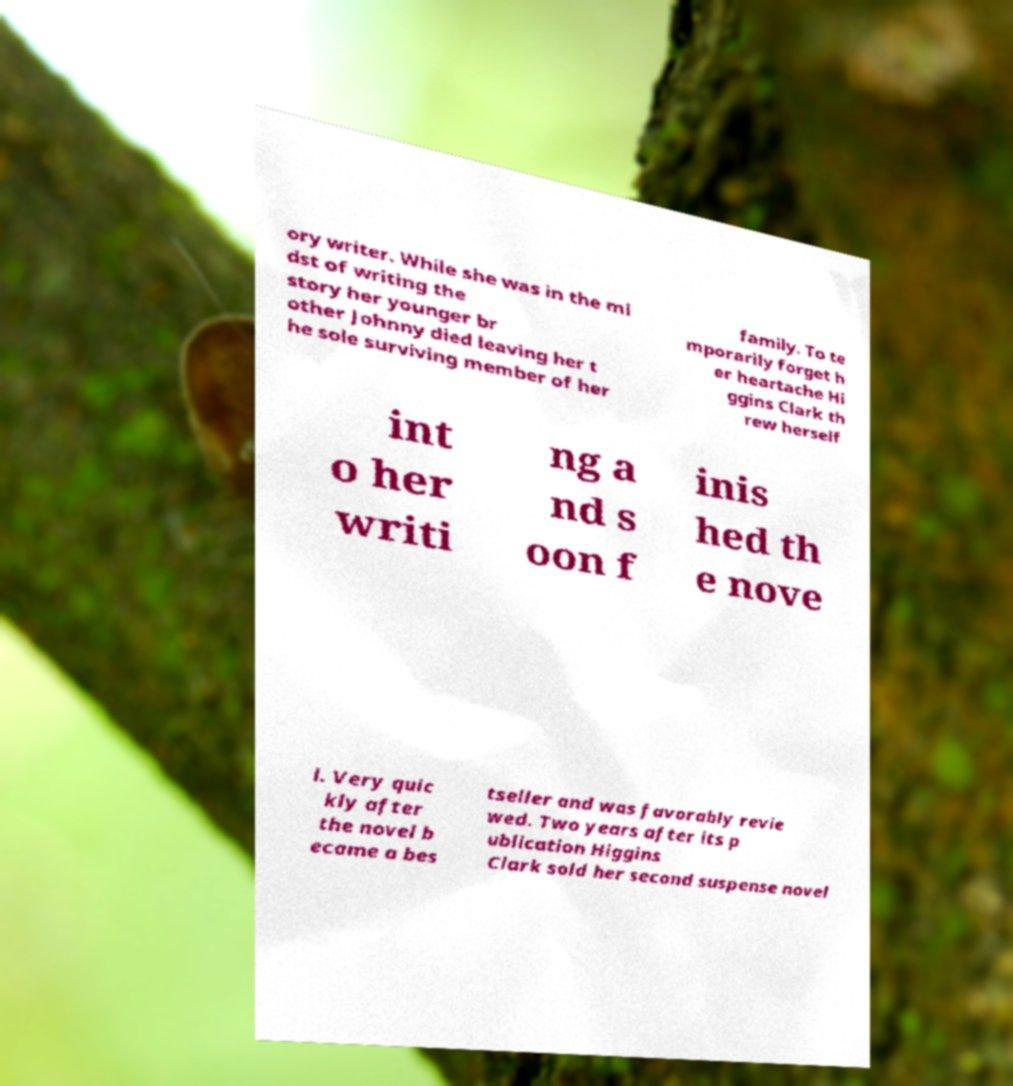For documentation purposes, I need the text within this image transcribed. Could you provide that? ory writer. While she was in the mi dst of writing the story her younger br other Johnny died leaving her t he sole surviving member of her family. To te mporarily forget h er heartache Hi ggins Clark th rew herself int o her writi ng a nd s oon f inis hed th e nove l. Very quic kly after the novel b ecame a bes tseller and was favorably revie wed. Two years after its p ublication Higgins Clark sold her second suspense novel 